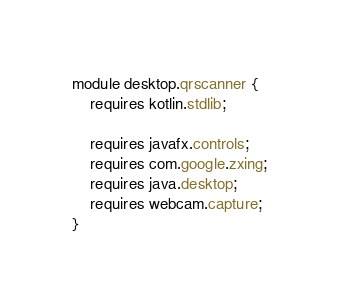Convert code to text. <code><loc_0><loc_0><loc_500><loc_500><_Java_>module desktop.qrscanner {
    requires kotlin.stdlib;

    requires javafx.controls;
    requires com.google.zxing;
    requires java.desktop;
    requires webcam.capture;
}</code> 